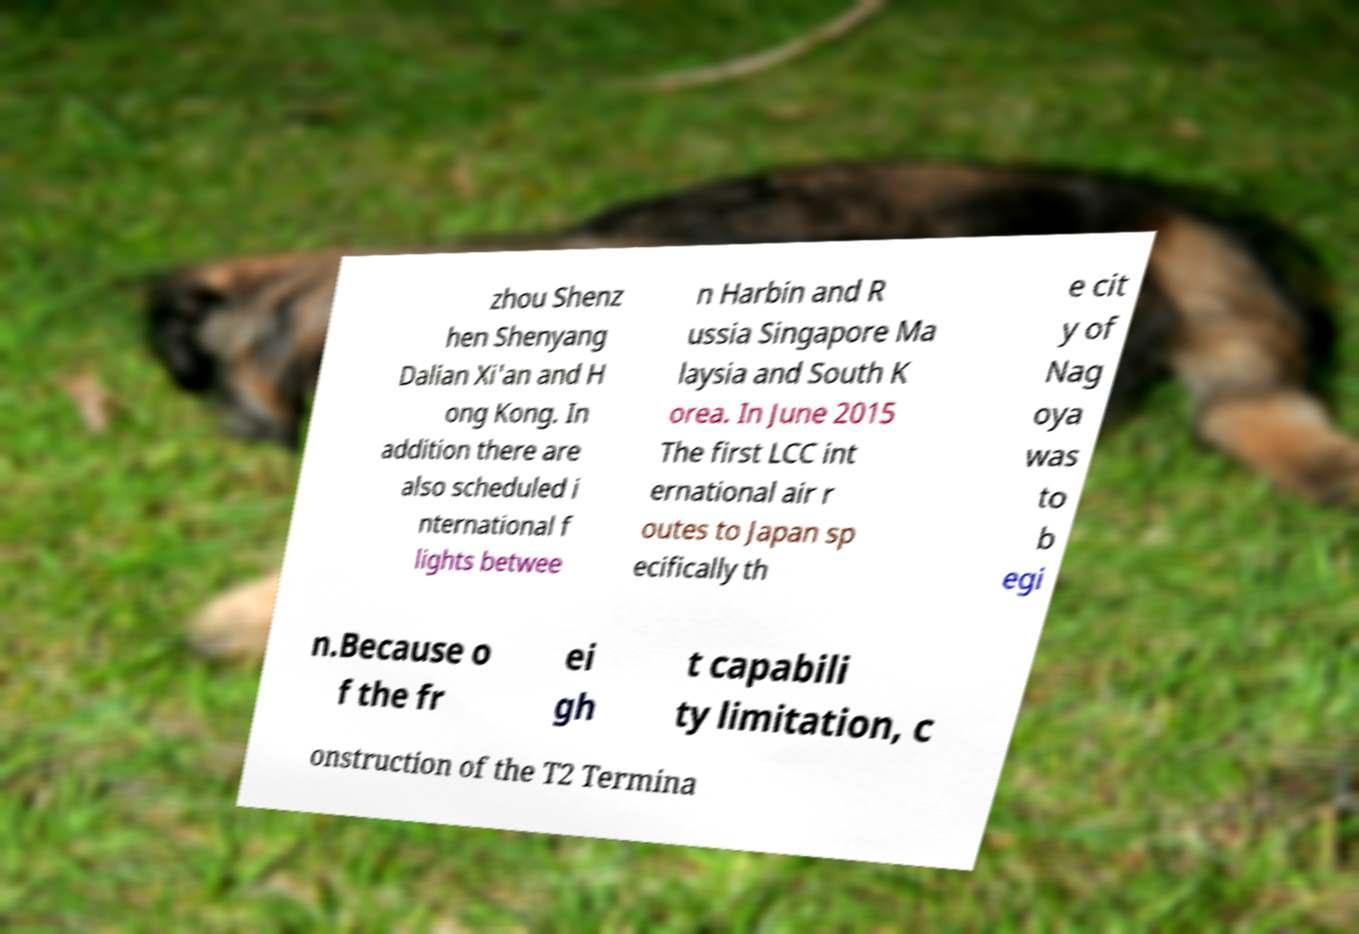Could you assist in decoding the text presented in this image and type it out clearly? zhou Shenz hen Shenyang Dalian Xi'an and H ong Kong. In addition there are also scheduled i nternational f lights betwee n Harbin and R ussia Singapore Ma laysia and South K orea. In June 2015 The first LCC int ernational air r outes to Japan sp ecifically th e cit y of Nag oya was to b egi n.Because o f the fr ei gh t capabili ty limitation, c onstruction of the T2 Termina 